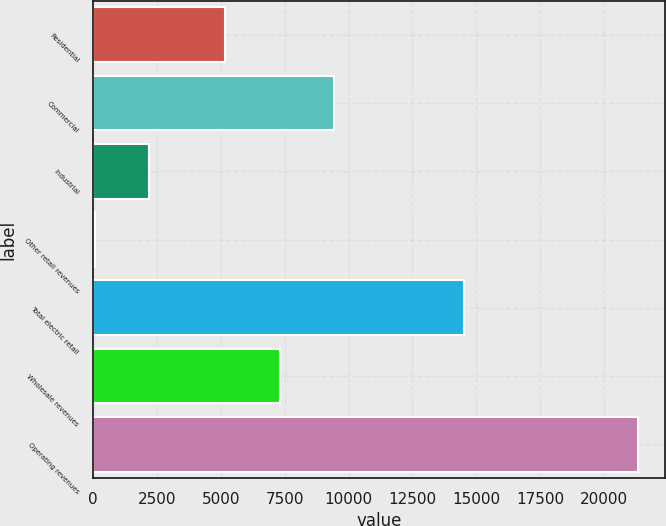Convert chart. <chart><loc_0><loc_0><loc_500><loc_500><bar_chart><fcel>Residential<fcel>Commercial<fcel>Industrial<fcel>Other retail revenues<fcel>Total electric retail<fcel>Wholesale revenues<fcel>Operating revenues<nl><fcel>5182<fcel>9432.2<fcel>2197.1<fcel>72<fcel>14535<fcel>7307.1<fcel>21323<nl></chart> 